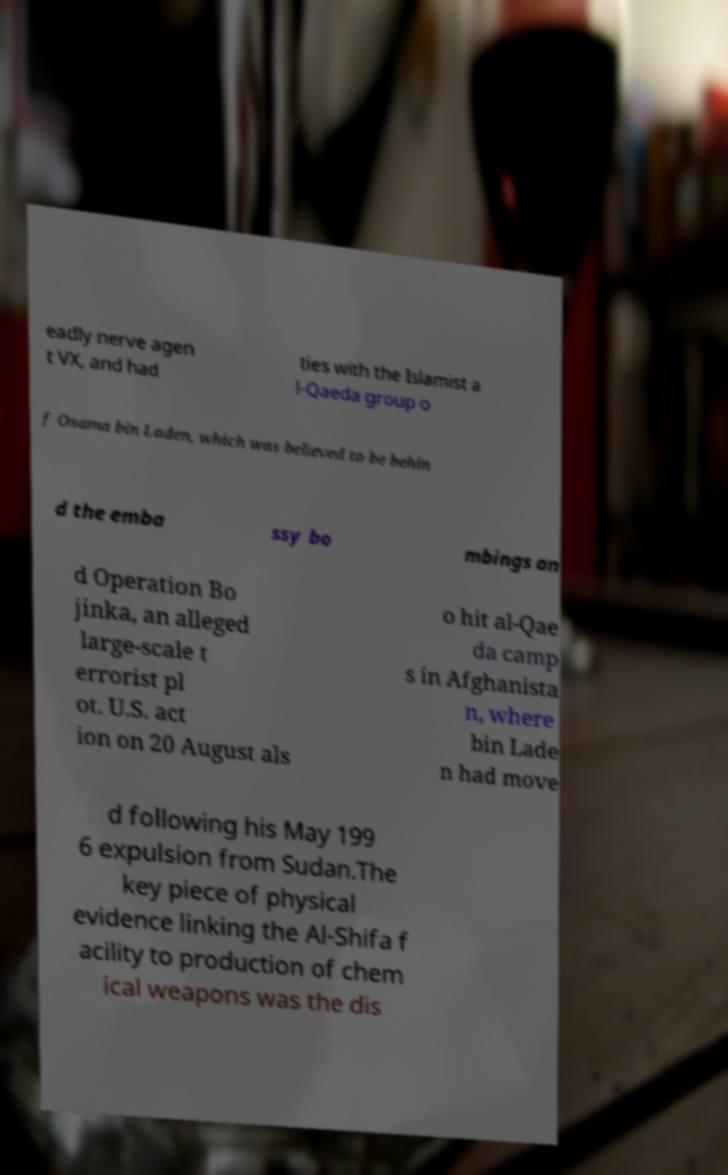Please identify and transcribe the text found in this image. eadly nerve agen t VX, and had ties with the Islamist a l-Qaeda group o f Osama bin Laden, which was believed to be behin d the emba ssy bo mbings an d Operation Bo jinka, an alleged large-scale t errorist pl ot. U.S. act ion on 20 August als o hit al-Qae da camp s in Afghanista n, where bin Lade n had move d following his May 199 6 expulsion from Sudan.The key piece of physical evidence linking the Al-Shifa f acility to production of chem ical weapons was the dis 